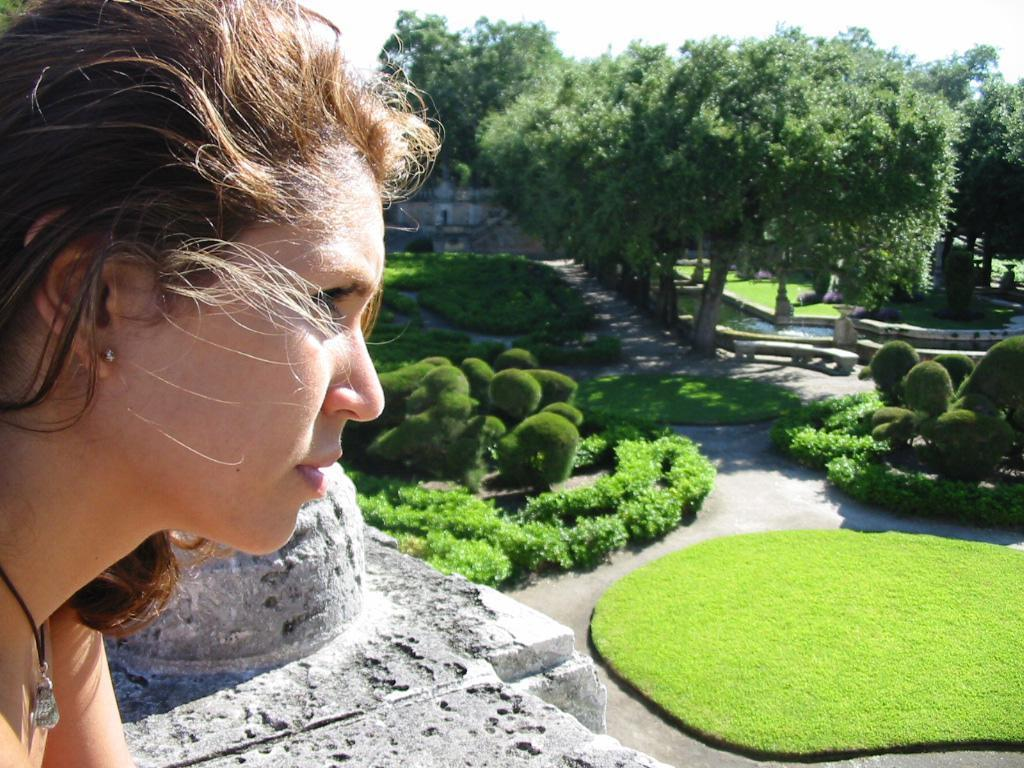Who is the main subject on the left side of the image? There is a woman on the left side of the image. Can you describe the woman's appearance? The woman has short hair. What type of natural elements can be seen in the image? There are trees, plants, grass, and stone in the image. What man-made structures are present in the image? There are benches and a road in the image. What part of the natural environment is visible in the image? The sky is visible in the image. What type of horn can be heard in the image? There is no horn or sound present in the image; it is a still image. 